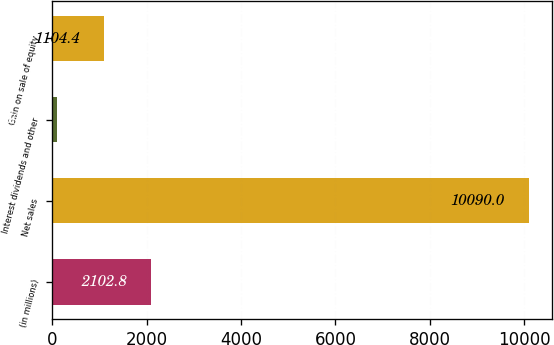Convert chart. <chart><loc_0><loc_0><loc_500><loc_500><bar_chart><fcel>(in millions)<fcel>Net sales<fcel>Interest dividends and other<fcel>Gain on sale of equity<nl><fcel>2102.8<fcel>10090<fcel>106<fcel>1104.4<nl></chart> 